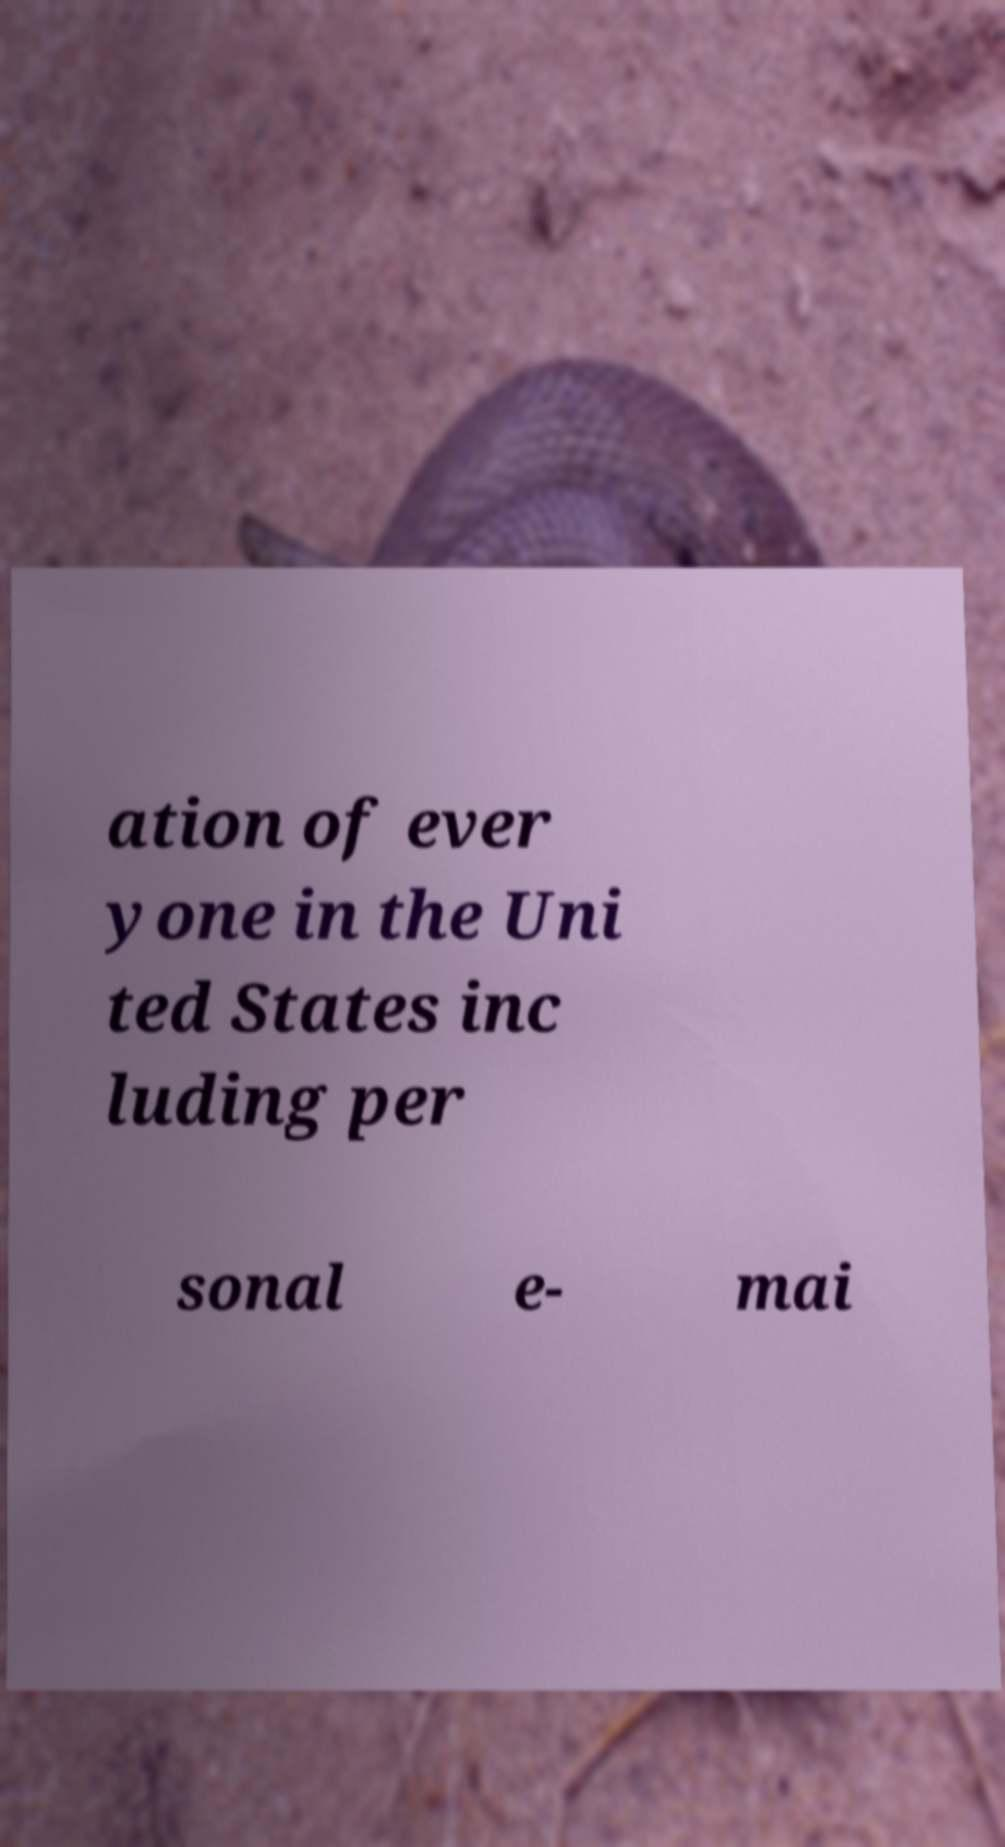Can you accurately transcribe the text from the provided image for me? ation of ever yone in the Uni ted States inc luding per sonal e- mai 